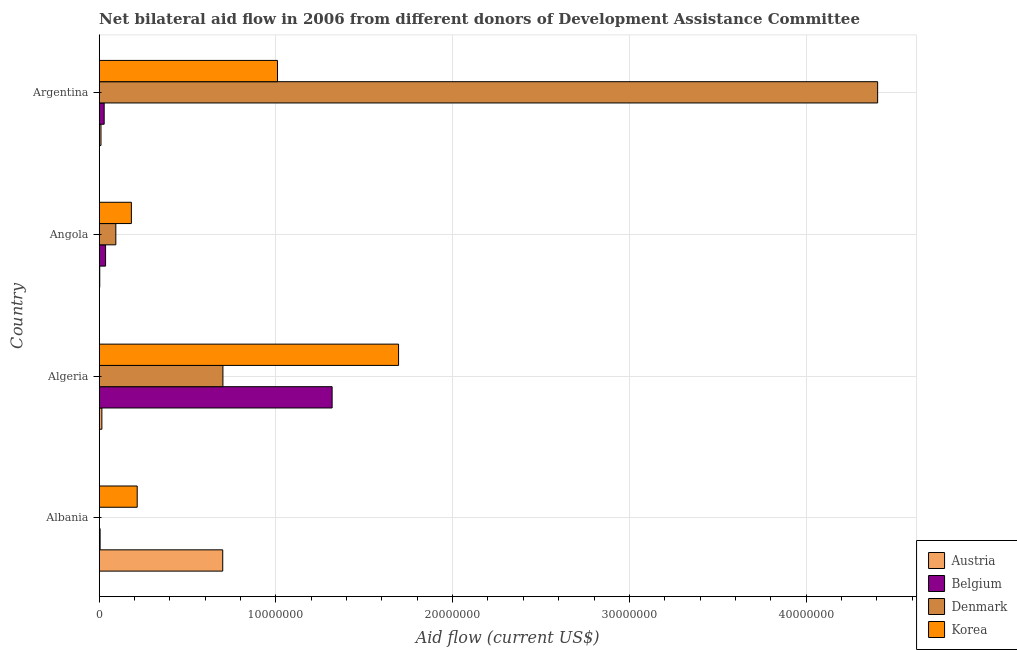How many different coloured bars are there?
Provide a short and direct response. 4. How many groups of bars are there?
Your response must be concise. 4. Are the number of bars per tick equal to the number of legend labels?
Your answer should be very brief. No. How many bars are there on the 4th tick from the top?
Make the answer very short. 3. How many bars are there on the 2nd tick from the bottom?
Provide a short and direct response. 4. What is the label of the 2nd group of bars from the top?
Give a very brief answer. Angola. What is the amount of aid given by denmark in Albania?
Provide a short and direct response. 0. Across all countries, what is the maximum amount of aid given by korea?
Keep it short and to the point. 1.69e+07. Across all countries, what is the minimum amount of aid given by korea?
Offer a very short reply. 1.82e+06. In which country was the amount of aid given by denmark maximum?
Offer a terse response. Argentina. What is the total amount of aid given by austria in the graph?
Your answer should be compact. 7.27e+06. What is the difference between the amount of aid given by korea in Algeria and that in Angola?
Your answer should be compact. 1.51e+07. What is the difference between the amount of aid given by denmark in Albania and the amount of aid given by korea in Algeria?
Offer a terse response. -1.69e+07. What is the average amount of aid given by belgium per country?
Provide a succinct answer. 3.47e+06. What is the difference between the amount of aid given by korea and amount of aid given by austria in Albania?
Your answer should be compact. -4.84e+06. In how many countries, is the amount of aid given by korea greater than 10000000 US$?
Offer a very short reply. 2. What is the difference between the highest and the second highest amount of aid given by denmark?
Ensure brevity in your answer.  3.70e+07. What is the difference between the highest and the lowest amount of aid given by austria?
Offer a terse response. 6.96e+06. Is the sum of the amount of aid given by belgium in Algeria and Argentina greater than the maximum amount of aid given by korea across all countries?
Your answer should be compact. No. Is it the case that in every country, the sum of the amount of aid given by austria and amount of aid given by belgium is greater than the amount of aid given by denmark?
Your answer should be very brief. No. Are all the bars in the graph horizontal?
Provide a short and direct response. Yes. How many countries are there in the graph?
Your answer should be compact. 4. What is the difference between two consecutive major ticks on the X-axis?
Make the answer very short. 1.00e+07. How many legend labels are there?
Offer a terse response. 4. How are the legend labels stacked?
Give a very brief answer. Vertical. What is the title of the graph?
Offer a very short reply. Net bilateral aid flow in 2006 from different donors of Development Assistance Committee. Does "Tertiary schools" appear as one of the legend labels in the graph?
Your answer should be compact. No. What is the label or title of the Y-axis?
Give a very brief answer. Country. What is the Aid flow (current US$) of Austria in Albania?
Your answer should be very brief. 6.99e+06. What is the Aid flow (current US$) in Belgium in Albania?
Provide a succinct answer. 5.00e+04. What is the Aid flow (current US$) in Denmark in Albania?
Your answer should be compact. 0. What is the Aid flow (current US$) of Korea in Albania?
Your answer should be very brief. 2.15e+06. What is the Aid flow (current US$) of Austria in Algeria?
Provide a short and direct response. 1.50e+05. What is the Aid flow (current US$) in Belgium in Algeria?
Give a very brief answer. 1.32e+07. What is the Aid flow (current US$) in Korea in Algeria?
Give a very brief answer. 1.69e+07. What is the Aid flow (current US$) of Austria in Angola?
Offer a very short reply. 3.00e+04. What is the Aid flow (current US$) of Denmark in Angola?
Keep it short and to the point. 9.40e+05. What is the Aid flow (current US$) of Korea in Angola?
Give a very brief answer. 1.82e+06. What is the Aid flow (current US$) in Denmark in Argentina?
Keep it short and to the point. 4.40e+07. What is the Aid flow (current US$) in Korea in Argentina?
Offer a very short reply. 1.01e+07. Across all countries, what is the maximum Aid flow (current US$) in Austria?
Give a very brief answer. 6.99e+06. Across all countries, what is the maximum Aid flow (current US$) in Belgium?
Provide a succinct answer. 1.32e+07. Across all countries, what is the maximum Aid flow (current US$) in Denmark?
Give a very brief answer. 4.40e+07. Across all countries, what is the maximum Aid flow (current US$) of Korea?
Ensure brevity in your answer.  1.69e+07. Across all countries, what is the minimum Aid flow (current US$) in Denmark?
Your response must be concise. 0. Across all countries, what is the minimum Aid flow (current US$) in Korea?
Keep it short and to the point. 1.82e+06. What is the total Aid flow (current US$) in Austria in the graph?
Provide a short and direct response. 7.27e+06. What is the total Aid flow (current US$) in Belgium in the graph?
Keep it short and to the point. 1.39e+07. What is the total Aid flow (current US$) in Denmark in the graph?
Ensure brevity in your answer.  5.20e+07. What is the total Aid flow (current US$) of Korea in the graph?
Your answer should be very brief. 3.10e+07. What is the difference between the Aid flow (current US$) of Austria in Albania and that in Algeria?
Your response must be concise. 6.84e+06. What is the difference between the Aid flow (current US$) of Belgium in Albania and that in Algeria?
Keep it short and to the point. -1.31e+07. What is the difference between the Aid flow (current US$) of Korea in Albania and that in Algeria?
Offer a very short reply. -1.48e+07. What is the difference between the Aid flow (current US$) in Austria in Albania and that in Angola?
Your answer should be compact. 6.96e+06. What is the difference between the Aid flow (current US$) in Belgium in Albania and that in Angola?
Offer a very short reply. -3.10e+05. What is the difference between the Aid flow (current US$) in Austria in Albania and that in Argentina?
Give a very brief answer. 6.89e+06. What is the difference between the Aid flow (current US$) in Korea in Albania and that in Argentina?
Make the answer very short. -7.94e+06. What is the difference between the Aid flow (current US$) of Belgium in Algeria and that in Angola?
Offer a terse response. 1.28e+07. What is the difference between the Aid flow (current US$) in Denmark in Algeria and that in Angola?
Keep it short and to the point. 6.06e+06. What is the difference between the Aid flow (current US$) of Korea in Algeria and that in Angola?
Give a very brief answer. 1.51e+07. What is the difference between the Aid flow (current US$) of Belgium in Algeria and that in Argentina?
Ensure brevity in your answer.  1.29e+07. What is the difference between the Aid flow (current US$) in Denmark in Algeria and that in Argentina?
Keep it short and to the point. -3.70e+07. What is the difference between the Aid flow (current US$) in Korea in Algeria and that in Argentina?
Keep it short and to the point. 6.85e+06. What is the difference between the Aid flow (current US$) in Belgium in Angola and that in Argentina?
Provide a short and direct response. 8.00e+04. What is the difference between the Aid flow (current US$) of Denmark in Angola and that in Argentina?
Give a very brief answer. -4.31e+07. What is the difference between the Aid flow (current US$) of Korea in Angola and that in Argentina?
Ensure brevity in your answer.  -8.27e+06. What is the difference between the Aid flow (current US$) of Austria in Albania and the Aid flow (current US$) of Belgium in Algeria?
Ensure brevity in your answer.  -6.19e+06. What is the difference between the Aid flow (current US$) of Austria in Albania and the Aid flow (current US$) of Denmark in Algeria?
Keep it short and to the point. -10000. What is the difference between the Aid flow (current US$) of Austria in Albania and the Aid flow (current US$) of Korea in Algeria?
Ensure brevity in your answer.  -9.95e+06. What is the difference between the Aid flow (current US$) in Belgium in Albania and the Aid flow (current US$) in Denmark in Algeria?
Provide a short and direct response. -6.95e+06. What is the difference between the Aid flow (current US$) of Belgium in Albania and the Aid flow (current US$) of Korea in Algeria?
Offer a terse response. -1.69e+07. What is the difference between the Aid flow (current US$) in Austria in Albania and the Aid flow (current US$) in Belgium in Angola?
Your answer should be very brief. 6.63e+06. What is the difference between the Aid flow (current US$) in Austria in Albania and the Aid flow (current US$) in Denmark in Angola?
Your answer should be very brief. 6.05e+06. What is the difference between the Aid flow (current US$) in Austria in Albania and the Aid flow (current US$) in Korea in Angola?
Keep it short and to the point. 5.17e+06. What is the difference between the Aid flow (current US$) in Belgium in Albania and the Aid flow (current US$) in Denmark in Angola?
Give a very brief answer. -8.90e+05. What is the difference between the Aid flow (current US$) in Belgium in Albania and the Aid flow (current US$) in Korea in Angola?
Keep it short and to the point. -1.77e+06. What is the difference between the Aid flow (current US$) in Austria in Albania and the Aid flow (current US$) in Belgium in Argentina?
Your answer should be compact. 6.71e+06. What is the difference between the Aid flow (current US$) in Austria in Albania and the Aid flow (current US$) in Denmark in Argentina?
Make the answer very short. -3.71e+07. What is the difference between the Aid flow (current US$) of Austria in Albania and the Aid flow (current US$) of Korea in Argentina?
Provide a short and direct response. -3.10e+06. What is the difference between the Aid flow (current US$) in Belgium in Albania and the Aid flow (current US$) in Denmark in Argentina?
Your answer should be compact. -4.40e+07. What is the difference between the Aid flow (current US$) in Belgium in Albania and the Aid flow (current US$) in Korea in Argentina?
Provide a short and direct response. -1.00e+07. What is the difference between the Aid flow (current US$) of Austria in Algeria and the Aid flow (current US$) of Belgium in Angola?
Provide a short and direct response. -2.10e+05. What is the difference between the Aid flow (current US$) in Austria in Algeria and the Aid flow (current US$) in Denmark in Angola?
Ensure brevity in your answer.  -7.90e+05. What is the difference between the Aid flow (current US$) in Austria in Algeria and the Aid flow (current US$) in Korea in Angola?
Your response must be concise. -1.67e+06. What is the difference between the Aid flow (current US$) of Belgium in Algeria and the Aid flow (current US$) of Denmark in Angola?
Provide a succinct answer. 1.22e+07. What is the difference between the Aid flow (current US$) of Belgium in Algeria and the Aid flow (current US$) of Korea in Angola?
Your answer should be very brief. 1.14e+07. What is the difference between the Aid flow (current US$) in Denmark in Algeria and the Aid flow (current US$) in Korea in Angola?
Your answer should be very brief. 5.18e+06. What is the difference between the Aid flow (current US$) in Austria in Algeria and the Aid flow (current US$) in Denmark in Argentina?
Offer a terse response. -4.39e+07. What is the difference between the Aid flow (current US$) of Austria in Algeria and the Aid flow (current US$) of Korea in Argentina?
Your answer should be very brief. -9.94e+06. What is the difference between the Aid flow (current US$) of Belgium in Algeria and the Aid flow (current US$) of Denmark in Argentina?
Your answer should be compact. -3.09e+07. What is the difference between the Aid flow (current US$) of Belgium in Algeria and the Aid flow (current US$) of Korea in Argentina?
Give a very brief answer. 3.09e+06. What is the difference between the Aid flow (current US$) of Denmark in Algeria and the Aid flow (current US$) of Korea in Argentina?
Your answer should be very brief. -3.09e+06. What is the difference between the Aid flow (current US$) in Austria in Angola and the Aid flow (current US$) in Denmark in Argentina?
Give a very brief answer. -4.40e+07. What is the difference between the Aid flow (current US$) of Austria in Angola and the Aid flow (current US$) of Korea in Argentina?
Provide a succinct answer. -1.01e+07. What is the difference between the Aid flow (current US$) of Belgium in Angola and the Aid flow (current US$) of Denmark in Argentina?
Provide a succinct answer. -4.37e+07. What is the difference between the Aid flow (current US$) in Belgium in Angola and the Aid flow (current US$) in Korea in Argentina?
Make the answer very short. -9.73e+06. What is the difference between the Aid flow (current US$) in Denmark in Angola and the Aid flow (current US$) in Korea in Argentina?
Offer a terse response. -9.15e+06. What is the average Aid flow (current US$) of Austria per country?
Your answer should be compact. 1.82e+06. What is the average Aid flow (current US$) of Belgium per country?
Make the answer very short. 3.47e+06. What is the average Aid flow (current US$) of Denmark per country?
Ensure brevity in your answer.  1.30e+07. What is the average Aid flow (current US$) of Korea per country?
Provide a succinct answer. 7.75e+06. What is the difference between the Aid flow (current US$) of Austria and Aid flow (current US$) of Belgium in Albania?
Your answer should be very brief. 6.94e+06. What is the difference between the Aid flow (current US$) of Austria and Aid flow (current US$) of Korea in Albania?
Your response must be concise. 4.84e+06. What is the difference between the Aid flow (current US$) of Belgium and Aid flow (current US$) of Korea in Albania?
Your answer should be compact. -2.10e+06. What is the difference between the Aid flow (current US$) of Austria and Aid flow (current US$) of Belgium in Algeria?
Your answer should be very brief. -1.30e+07. What is the difference between the Aid flow (current US$) of Austria and Aid flow (current US$) of Denmark in Algeria?
Give a very brief answer. -6.85e+06. What is the difference between the Aid flow (current US$) of Austria and Aid flow (current US$) of Korea in Algeria?
Your answer should be very brief. -1.68e+07. What is the difference between the Aid flow (current US$) in Belgium and Aid flow (current US$) in Denmark in Algeria?
Offer a terse response. 6.18e+06. What is the difference between the Aid flow (current US$) of Belgium and Aid flow (current US$) of Korea in Algeria?
Your response must be concise. -3.76e+06. What is the difference between the Aid flow (current US$) of Denmark and Aid flow (current US$) of Korea in Algeria?
Your response must be concise. -9.94e+06. What is the difference between the Aid flow (current US$) of Austria and Aid flow (current US$) of Belgium in Angola?
Keep it short and to the point. -3.30e+05. What is the difference between the Aid flow (current US$) in Austria and Aid flow (current US$) in Denmark in Angola?
Offer a terse response. -9.10e+05. What is the difference between the Aid flow (current US$) of Austria and Aid flow (current US$) of Korea in Angola?
Offer a terse response. -1.79e+06. What is the difference between the Aid flow (current US$) in Belgium and Aid flow (current US$) in Denmark in Angola?
Your response must be concise. -5.80e+05. What is the difference between the Aid flow (current US$) in Belgium and Aid flow (current US$) in Korea in Angola?
Offer a very short reply. -1.46e+06. What is the difference between the Aid flow (current US$) of Denmark and Aid flow (current US$) of Korea in Angola?
Provide a short and direct response. -8.80e+05. What is the difference between the Aid flow (current US$) of Austria and Aid flow (current US$) of Denmark in Argentina?
Keep it short and to the point. -4.40e+07. What is the difference between the Aid flow (current US$) in Austria and Aid flow (current US$) in Korea in Argentina?
Provide a succinct answer. -9.99e+06. What is the difference between the Aid flow (current US$) of Belgium and Aid flow (current US$) of Denmark in Argentina?
Provide a short and direct response. -4.38e+07. What is the difference between the Aid flow (current US$) in Belgium and Aid flow (current US$) in Korea in Argentina?
Ensure brevity in your answer.  -9.81e+06. What is the difference between the Aid flow (current US$) of Denmark and Aid flow (current US$) of Korea in Argentina?
Your response must be concise. 3.40e+07. What is the ratio of the Aid flow (current US$) in Austria in Albania to that in Algeria?
Offer a terse response. 46.6. What is the ratio of the Aid flow (current US$) of Belgium in Albania to that in Algeria?
Your response must be concise. 0. What is the ratio of the Aid flow (current US$) of Korea in Albania to that in Algeria?
Provide a short and direct response. 0.13. What is the ratio of the Aid flow (current US$) of Austria in Albania to that in Angola?
Make the answer very short. 233. What is the ratio of the Aid flow (current US$) of Belgium in Albania to that in Angola?
Provide a succinct answer. 0.14. What is the ratio of the Aid flow (current US$) of Korea in Albania to that in Angola?
Keep it short and to the point. 1.18. What is the ratio of the Aid flow (current US$) of Austria in Albania to that in Argentina?
Your response must be concise. 69.9. What is the ratio of the Aid flow (current US$) in Belgium in Albania to that in Argentina?
Keep it short and to the point. 0.18. What is the ratio of the Aid flow (current US$) of Korea in Albania to that in Argentina?
Ensure brevity in your answer.  0.21. What is the ratio of the Aid flow (current US$) in Austria in Algeria to that in Angola?
Your answer should be compact. 5. What is the ratio of the Aid flow (current US$) of Belgium in Algeria to that in Angola?
Ensure brevity in your answer.  36.61. What is the ratio of the Aid flow (current US$) in Denmark in Algeria to that in Angola?
Keep it short and to the point. 7.45. What is the ratio of the Aid flow (current US$) in Korea in Algeria to that in Angola?
Your response must be concise. 9.31. What is the ratio of the Aid flow (current US$) of Belgium in Algeria to that in Argentina?
Keep it short and to the point. 47.07. What is the ratio of the Aid flow (current US$) in Denmark in Algeria to that in Argentina?
Make the answer very short. 0.16. What is the ratio of the Aid flow (current US$) of Korea in Algeria to that in Argentina?
Ensure brevity in your answer.  1.68. What is the ratio of the Aid flow (current US$) in Austria in Angola to that in Argentina?
Provide a succinct answer. 0.3. What is the ratio of the Aid flow (current US$) of Denmark in Angola to that in Argentina?
Make the answer very short. 0.02. What is the ratio of the Aid flow (current US$) in Korea in Angola to that in Argentina?
Give a very brief answer. 0.18. What is the difference between the highest and the second highest Aid flow (current US$) of Austria?
Keep it short and to the point. 6.84e+06. What is the difference between the highest and the second highest Aid flow (current US$) in Belgium?
Keep it short and to the point. 1.28e+07. What is the difference between the highest and the second highest Aid flow (current US$) in Denmark?
Ensure brevity in your answer.  3.70e+07. What is the difference between the highest and the second highest Aid flow (current US$) in Korea?
Provide a succinct answer. 6.85e+06. What is the difference between the highest and the lowest Aid flow (current US$) of Austria?
Keep it short and to the point. 6.96e+06. What is the difference between the highest and the lowest Aid flow (current US$) in Belgium?
Give a very brief answer. 1.31e+07. What is the difference between the highest and the lowest Aid flow (current US$) in Denmark?
Give a very brief answer. 4.40e+07. What is the difference between the highest and the lowest Aid flow (current US$) in Korea?
Provide a succinct answer. 1.51e+07. 